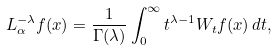<formula> <loc_0><loc_0><loc_500><loc_500>L _ { \alpha } ^ { - \lambda } f ( x ) = \frac { 1 } { \Gamma ( \lambda ) } \int _ { 0 } ^ { \infty } t ^ { \lambda - 1 } W _ { t } f ( x ) \, d t ,</formula> 